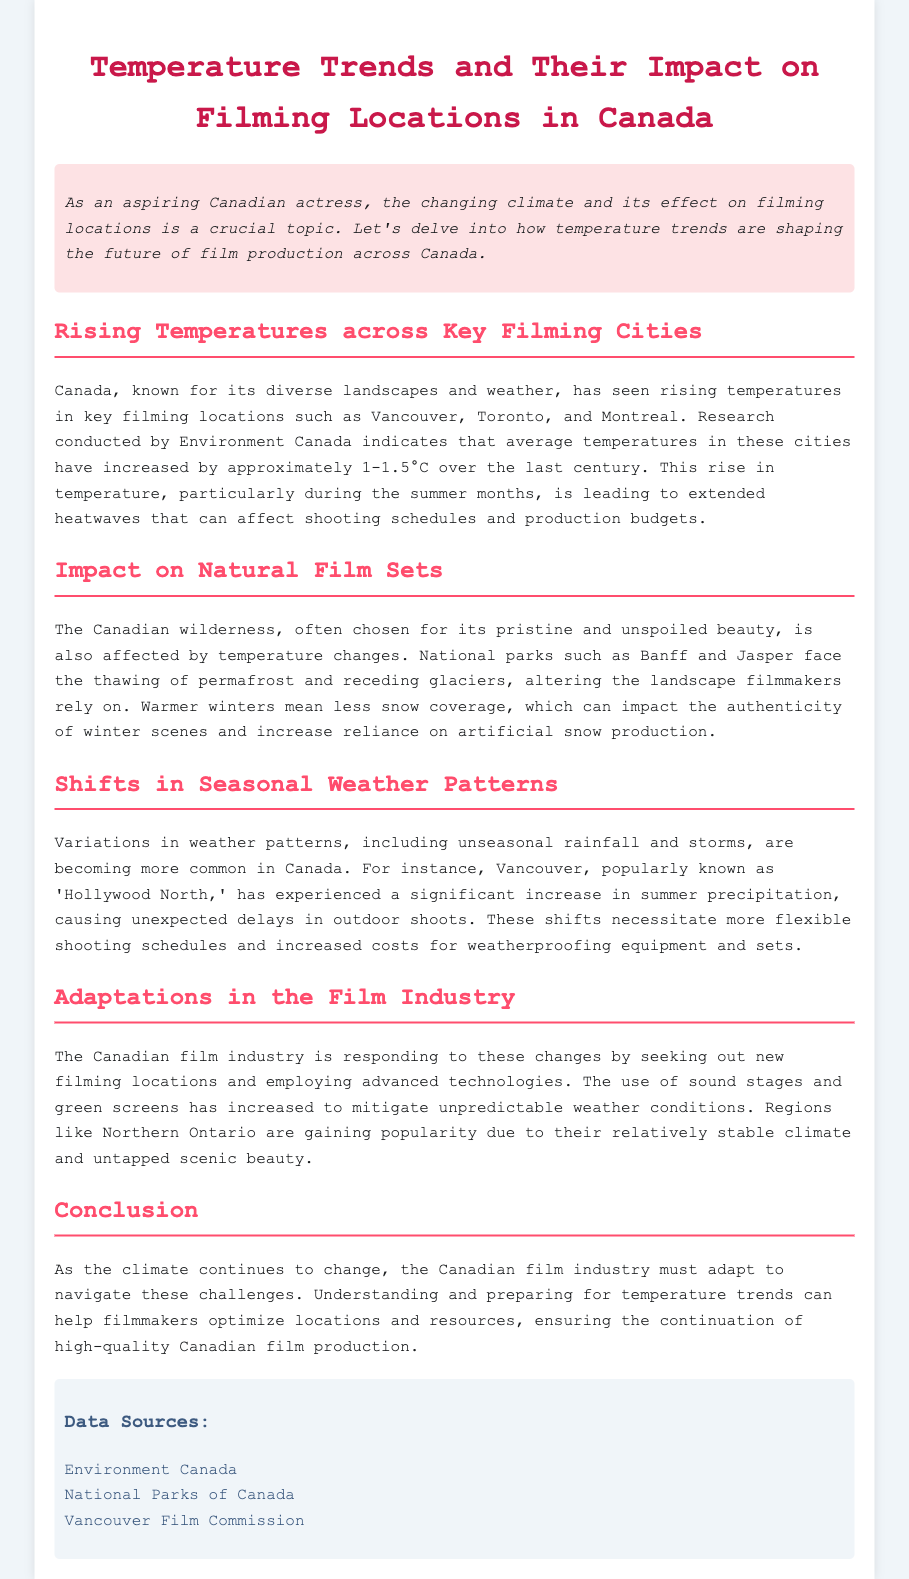What are the key filming cities mentioned? The document lists Vancouver, Toronto, and Montreal as key filming cities affected by rising temperatures.
Answer: Vancouver, Toronto, Montreal How much have average temperatures increased in Canada? The report mentions that average temperatures have increased by approximately 1-1.5°C over the last century.
Answer: 1-1.5°C What is a major consequence of warmer winters for filmmakers? Warmer winters lead to less snow coverage, affecting the authenticity of winter scenes and increasing reliance on artificial snow production.
Answer: Less snow coverage Which region is gaining popularity for filming due to stable climate? Northern Ontario is noted as gaining popularity due to its relatively stable climate and scenic beauty.
Answer: Northern Ontario What type of technologies is the film industry employing to adapt? The Canadian film industry is increasing the use of sound stages and green screens to mitigate unpredictable weather conditions.
Answer: Sound stages, green screens What was the impact of increased summer precipitation in Vancouver? Increased summer precipitation in Vancouver has caused unexpected delays in outdoor shoots.
Answer: Unexpected delays What does the conclusion emphasize regarding the film industry? The conclusion emphasizes the need for the Canadian film industry to adapt and prepare for temperature trends to continue high-quality production.
Answer: Adapt and prepare What is the primary subject of the document? The document discusses temperature trends and their impact on filming locations in Canada.
Answer: Temperature trends and their impact on filming locations 